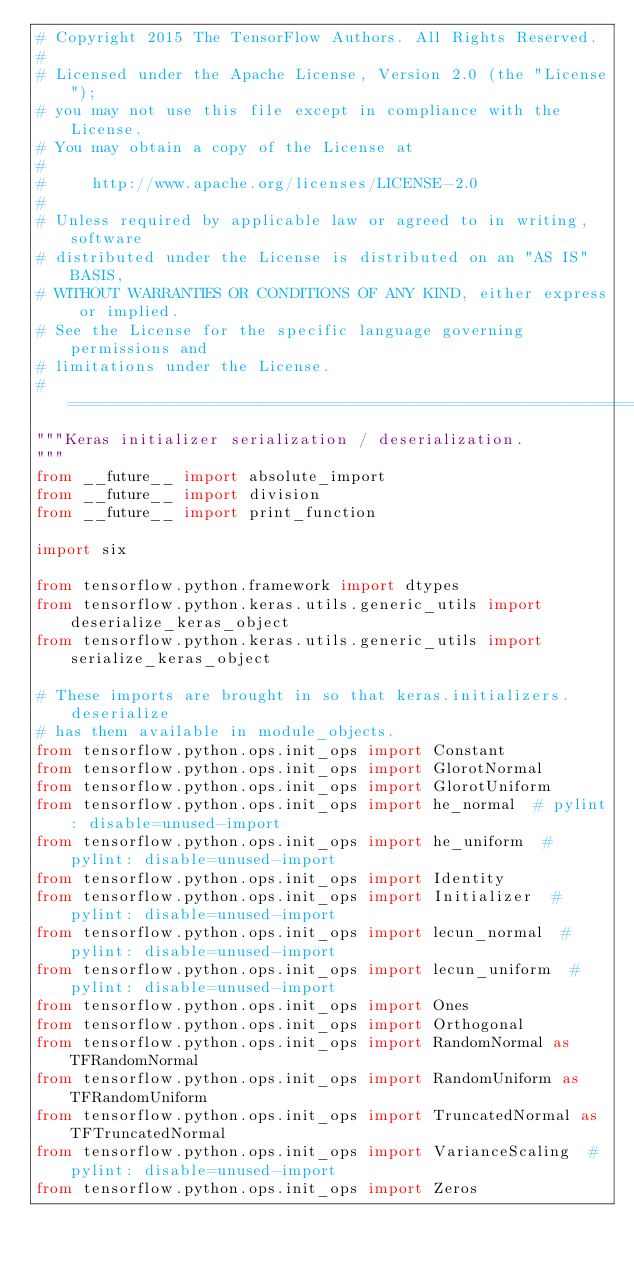<code> <loc_0><loc_0><loc_500><loc_500><_Python_># Copyright 2015 The TensorFlow Authors. All Rights Reserved.
#
# Licensed under the Apache License, Version 2.0 (the "License");
# you may not use this file except in compliance with the License.
# You may obtain a copy of the License at
#
#     http://www.apache.org/licenses/LICENSE-2.0
#
# Unless required by applicable law or agreed to in writing, software
# distributed under the License is distributed on an "AS IS" BASIS,
# WITHOUT WARRANTIES OR CONDITIONS OF ANY KIND, either express or implied.
# See the License for the specific language governing permissions and
# limitations under the License.
# ==============================================================================
"""Keras initializer serialization / deserialization.
"""
from __future__ import absolute_import
from __future__ import division
from __future__ import print_function

import six

from tensorflow.python.framework import dtypes
from tensorflow.python.keras.utils.generic_utils import deserialize_keras_object
from tensorflow.python.keras.utils.generic_utils import serialize_keras_object

# These imports are brought in so that keras.initializers.deserialize
# has them available in module_objects.
from tensorflow.python.ops.init_ops import Constant
from tensorflow.python.ops.init_ops import GlorotNormal
from tensorflow.python.ops.init_ops import GlorotUniform
from tensorflow.python.ops.init_ops import he_normal  # pylint: disable=unused-import
from tensorflow.python.ops.init_ops import he_uniform  # pylint: disable=unused-import
from tensorflow.python.ops.init_ops import Identity
from tensorflow.python.ops.init_ops import Initializer  # pylint: disable=unused-import
from tensorflow.python.ops.init_ops import lecun_normal  # pylint: disable=unused-import
from tensorflow.python.ops.init_ops import lecun_uniform  # pylint: disable=unused-import
from tensorflow.python.ops.init_ops import Ones
from tensorflow.python.ops.init_ops import Orthogonal
from tensorflow.python.ops.init_ops import RandomNormal as TFRandomNormal
from tensorflow.python.ops.init_ops import RandomUniform as TFRandomUniform
from tensorflow.python.ops.init_ops import TruncatedNormal as TFTruncatedNormal
from tensorflow.python.ops.init_ops import VarianceScaling  # pylint: disable=unused-import
from tensorflow.python.ops.init_ops import Zeros</code> 